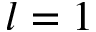Convert formula to latex. <formula><loc_0><loc_0><loc_500><loc_500>l = 1</formula> 